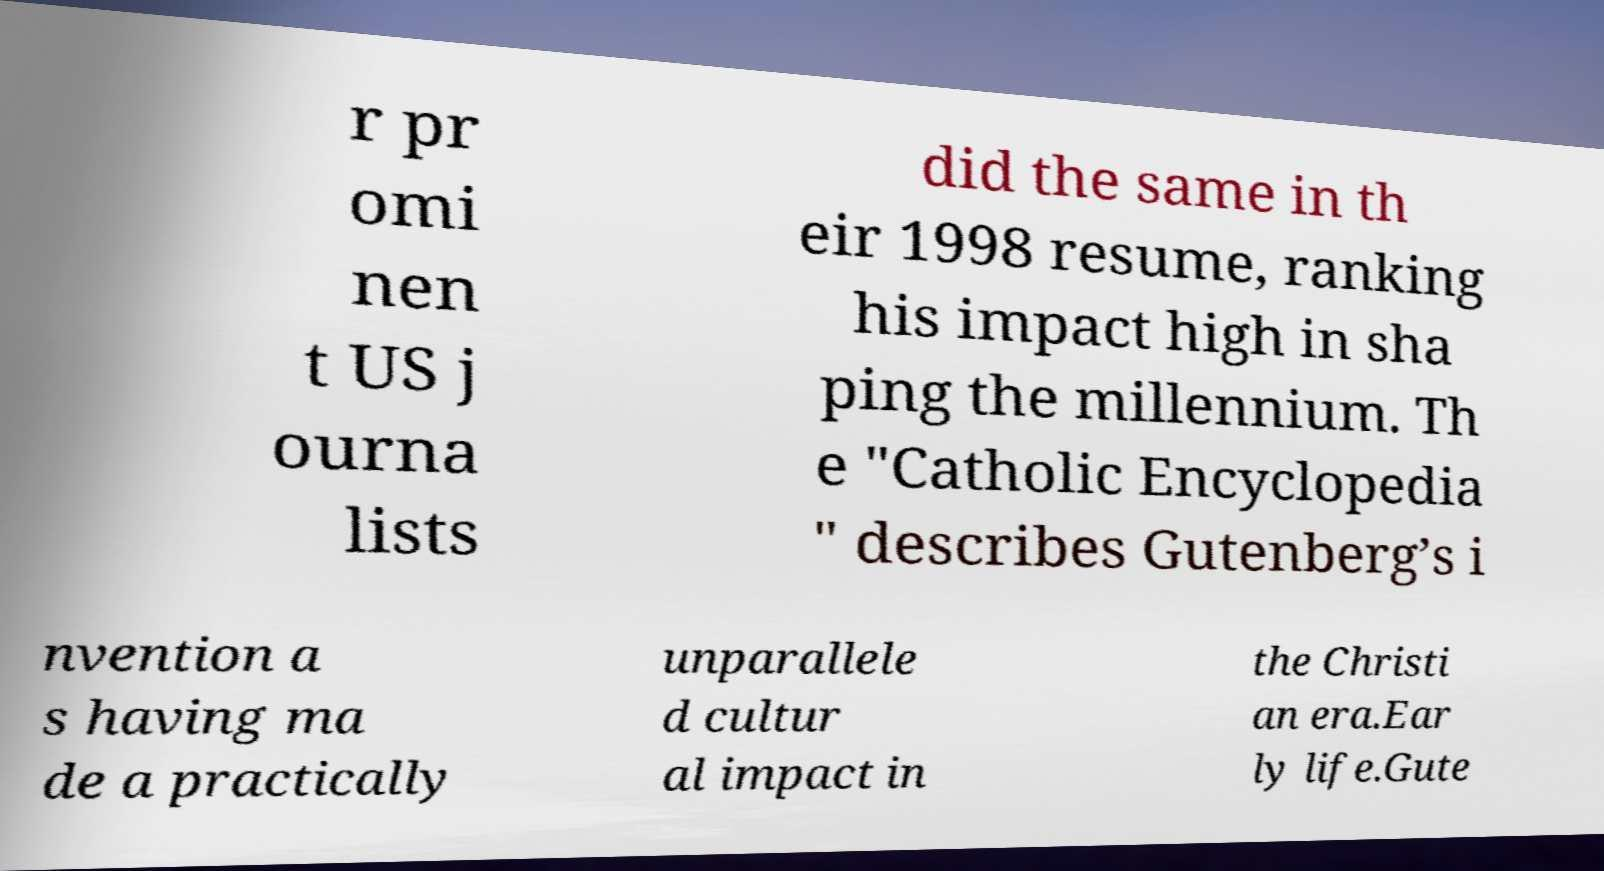Could you extract and type out the text from this image? r pr omi nen t US j ourna lists did the same in th eir 1998 resume, ranking his impact high in sha ping the millennium. Th e "Catholic Encyclopedia " describes Gutenberg’s i nvention a s having ma de a practically unparallele d cultur al impact in the Christi an era.Ear ly life.Gute 